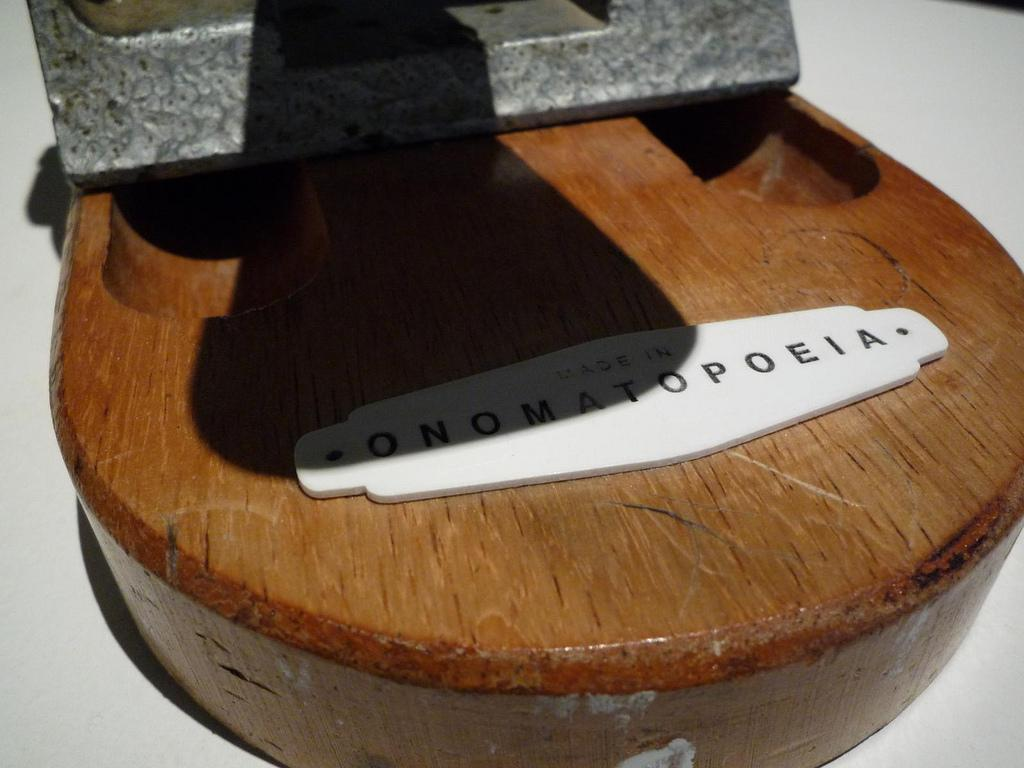What is the shape of the wooden object in the image? The wooden object in the image is round. What material is the wooden object made of? The wooden object is made of wood. What is placed on the wooden object? There is iron metal on the wooden plank. How many cherries are hanging from the wooden plank in the image? There are no cherries present in the image; it only features a round wooden plank with iron metal on it. 